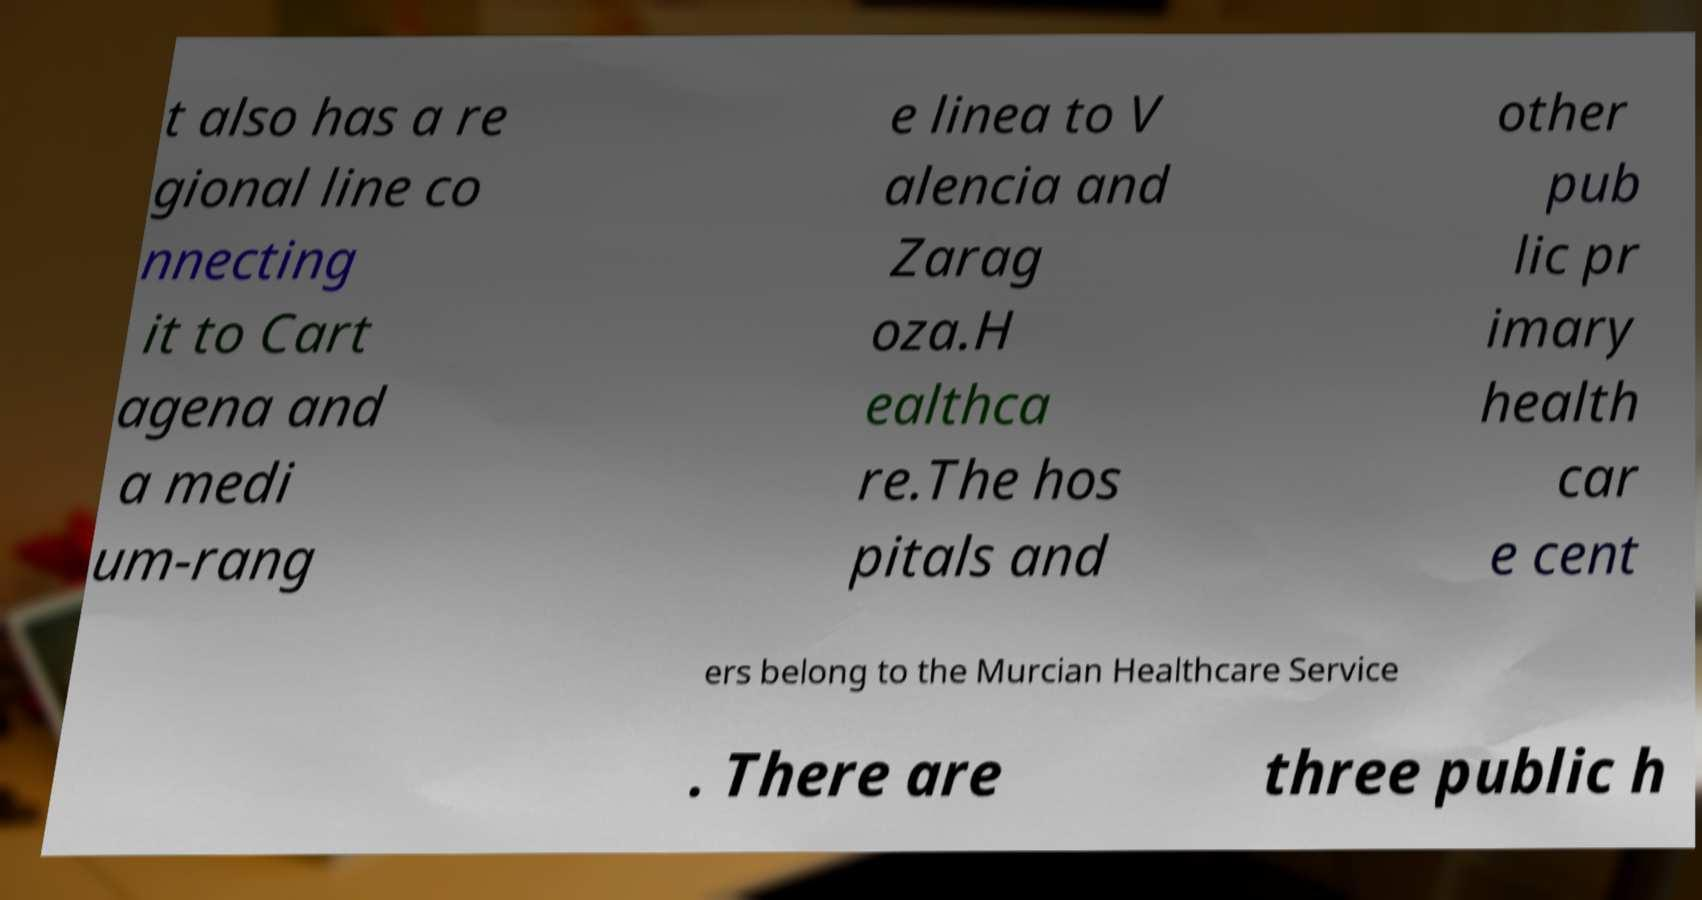There's text embedded in this image that I need extracted. Can you transcribe it verbatim? t also has a re gional line co nnecting it to Cart agena and a medi um-rang e linea to V alencia and Zarag oza.H ealthca re.The hos pitals and other pub lic pr imary health car e cent ers belong to the Murcian Healthcare Service . There are three public h 